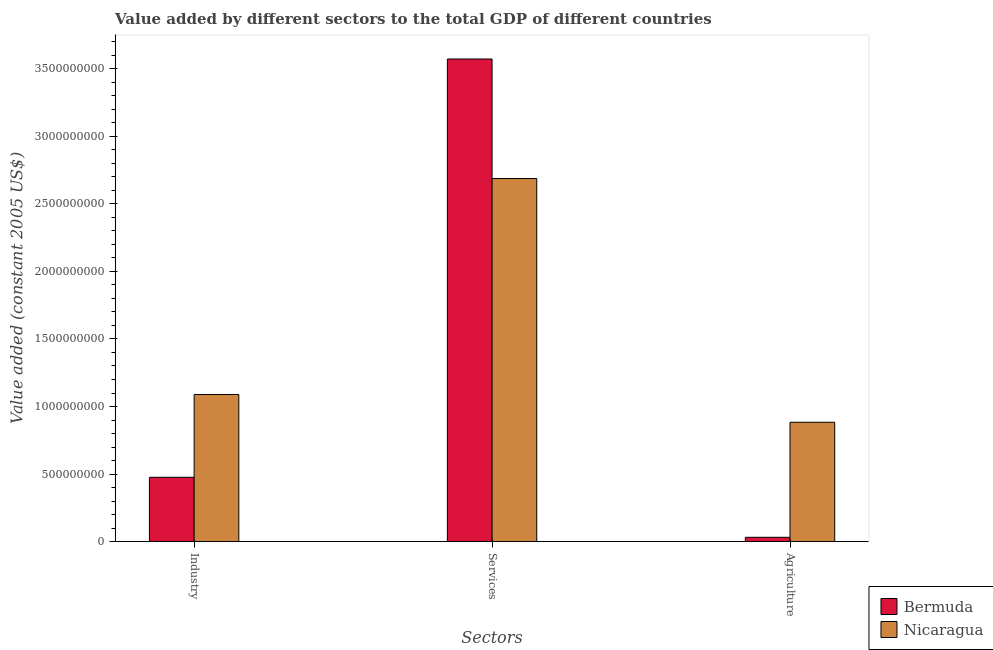How many different coloured bars are there?
Your response must be concise. 2. Are the number of bars per tick equal to the number of legend labels?
Your answer should be very brief. Yes. Are the number of bars on each tick of the X-axis equal?
Give a very brief answer. Yes. What is the label of the 1st group of bars from the left?
Your answer should be compact. Industry. What is the value added by agricultural sector in Bermuda?
Keep it short and to the point. 3.15e+07. Across all countries, what is the maximum value added by agricultural sector?
Make the answer very short. 8.83e+08. Across all countries, what is the minimum value added by agricultural sector?
Keep it short and to the point. 3.15e+07. In which country was the value added by agricultural sector maximum?
Offer a very short reply. Nicaragua. In which country was the value added by industrial sector minimum?
Provide a succinct answer. Bermuda. What is the total value added by services in the graph?
Offer a very short reply. 6.26e+09. What is the difference between the value added by services in Bermuda and that in Nicaragua?
Offer a very short reply. 8.85e+08. What is the difference between the value added by agricultural sector in Bermuda and the value added by industrial sector in Nicaragua?
Make the answer very short. -1.06e+09. What is the average value added by services per country?
Make the answer very short. 3.13e+09. What is the difference between the value added by agricultural sector and value added by industrial sector in Nicaragua?
Offer a terse response. -2.06e+08. In how many countries, is the value added by industrial sector greater than 2600000000 US$?
Your answer should be compact. 0. What is the ratio of the value added by services in Nicaragua to that in Bermuda?
Offer a very short reply. 0.75. What is the difference between the highest and the second highest value added by services?
Give a very brief answer. 8.85e+08. What is the difference between the highest and the lowest value added by industrial sector?
Your response must be concise. 6.13e+08. In how many countries, is the value added by services greater than the average value added by services taken over all countries?
Ensure brevity in your answer.  1. Is the sum of the value added by agricultural sector in Nicaragua and Bermuda greater than the maximum value added by industrial sector across all countries?
Your response must be concise. No. What does the 2nd bar from the left in Agriculture represents?
Make the answer very short. Nicaragua. What does the 2nd bar from the right in Services represents?
Provide a succinct answer. Bermuda. Is it the case that in every country, the sum of the value added by industrial sector and value added by services is greater than the value added by agricultural sector?
Your answer should be compact. Yes. How many bars are there?
Keep it short and to the point. 6. Are the values on the major ticks of Y-axis written in scientific E-notation?
Offer a very short reply. No. Does the graph contain any zero values?
Your response must be concise. No. Where does the legend appear in the graph?
Ensure brevity in your answer.  Bottom right. How many legend labels are there?
Provide a short and direct response. 2. What is the title of the graph?
Your response must be concise. Value added by different sectors to the total GDP of different countries. Does "Bahrain" appear as one of the legend labels in the graph?
Offer a terse response. No. What is the label or title of the X-axis?
Offer a very short reply. Sectors. What is the label or title of the Y-axis?
Make the answer very short. Value added (constant 2005 US$). What is the Value added (constant 2005 US$) of Bermuda in Industry?
Make the answer very short. 4.76e+08. What is the Value added (constant 2005 US$) in Nicaragua in Industry?
Your answer should be compact. 1.09e+09. What is the Value added (constant 2005 US$) of Bermuda in Services?
Offer a terse response. 3.57e+09. What is the Value added (constant 2005 US$) in Nicaragua in Services?
Provide a short and direct response. 2.69e+09. What is the Value added (constant 2005 US$) in Bermuda in Agriculture?
Offer a very short reply. 3.15e+07. What is the Value added (constant 2005 US$) in Nicaragua in Agriculture?
Your answer should be compact. 8.83e+08. Across all Sectors, what is the maximum Value added (constant 2005 US$) in Bermuda?
Ensure brevity in your answer.  3.57e+09. Across all Sectors, what is the maximum Value added (constant 2005 US$) of Nicaragua?
Ensure brevity in your answer.  2.69e+09. Across all Sectors, what is the minimum Value added (constant 2005 US$) in Bermuda?
Offer a very short reply. 3.15e+07. Across all Sectors, what is the minimum Value added (constant 2005 US$) in Nicaragua?
Offer a very short reply. 8.83e+08. What is the total Value added (constant 2005 US$) in Bermuda in the graph?
Offer a terse response. 4.08e+09. What is the total Value added (constant 2005 US$) of Nicaragua in the graph?
Offer a terse response. 4.66e+09. What is the difference between the Value added (constant 2005 US$) of Bermuda in Industry and that in Services?
Ensure brevity in your answer.  -3.10e+09. What is the difference between the Value added (constant 2005 US$) of Nicaragua in Industry and that in Services?
Your answer should be very brief. -1.60e+09. What is the difference between the Value added (constant 2005 US$) of Bermuda in Industry and that in Agriculture?
Your response must be concise. 4.44e+08. What is the difference between the Value added (constant 2005 US$) in Nicaragua in Industry and that in Agriculture?
Your response must be concise. 2.06e+08. What is the difference between the Value added (constant 2005 US$) in Bermuda in Services and that in Agriculture?
Your answer should be compact. 3.54e+09. What is the difference between the Value added (constant 2005 US$) in Nicaragua in Services and that in Agriculture?
Ensure brevity in your answer.  1.80e+09. What is the difference between the Value added (constant 2005 US$) of Bermuda in Industry and the Value added (constant 2005 US$) of Nicaragua in Services?
Offer a very short reply. -2.21e+09. What is the difference between the Value added (constant 2005 US$) in Bermuda in Industry and the Value added (constant 2005 US$) in Nicaragua in Agriculture?
Your answer should be very brief. -4.08e+08. What is the difference between the Value added (constant 2005 US$) in Bermuda in Services and the Value added (constant 2005 US$) in Nicaragua in Agriculture?
Keep it short and to the point. 2.69e+09. What is the average Value added (constant 2005 US$) in Bermuda per Sectors?
Your response must be concise. 1.36e+09. What is the average Value added (constant 2005 US$) in Nicaragua per Sectors?
Your answer should be compact. 1.55e+09. What is the difference between the Value added (constant 2005 US$) in Bermuda and Value added (constant 2005 US$) in Nicaragua in Industry?
Ensure brevity in your answer.  -6.13e+08. What is the difference between the Value added (constant 2005 US$) in Bermuda and Value added (constant 2005 US$) in Nicaragua in Services?
Offer a very short reply. 8.85e+08. What is the difference between the Value added (constant 2005 US$) of Bermuda and Value added (constant 2005 US$) of Nicaragua in Agriculture?
Provide a succinct answer. -8.52e+08. What is the ratio of the Value added (constant 2005 US$) in Bermuda in Industry to that in Services?
Your response must be concise. 0.13. What is the ratio of the Value added (constant 2005 US$) in Nicaragua in Industry to that in Services?
Provide a short and direct response. 0.41. What is the ratio of the Value added (constant 2005 US$) in Bermuda in Industry to that in Agriculture?
Provide a succinct answer. 15.09. What is the ratio of the Value added (constant 2005 US$) in Nicaragua in Industry to that in Agriculture?
Make the answer very short. 1.23. What is the ratio of the Value added (constant 2005 US$) in Bermuda in Services to that in Agriculture?
Keep it short and to the point. 113.32. What is the ratio of the Value added (constant 2005 US$) in Nicaragua in Services to that in Agriculture?
Offer a very short reply. 3.04. What is the difference between the highest and the second highest Value added (constant 2005 US$) in Bermuda?
Keep it short and to the point. 3.10e+09. What is the difference between the highest and the second highest Value added (constant 2005 US$) of Nicaragua?
Your response must be concise. 1.60e+09. What is the difference between the highest and the lowest Value added (constant 2005 US$) in Bermuda?
Your answer should be very brief. 3.54e+09. What is the difference between the highest and the lowest Value added (constant 2005 US$) in Nicaragua?
Offer a terse response. 1.80e+09. 